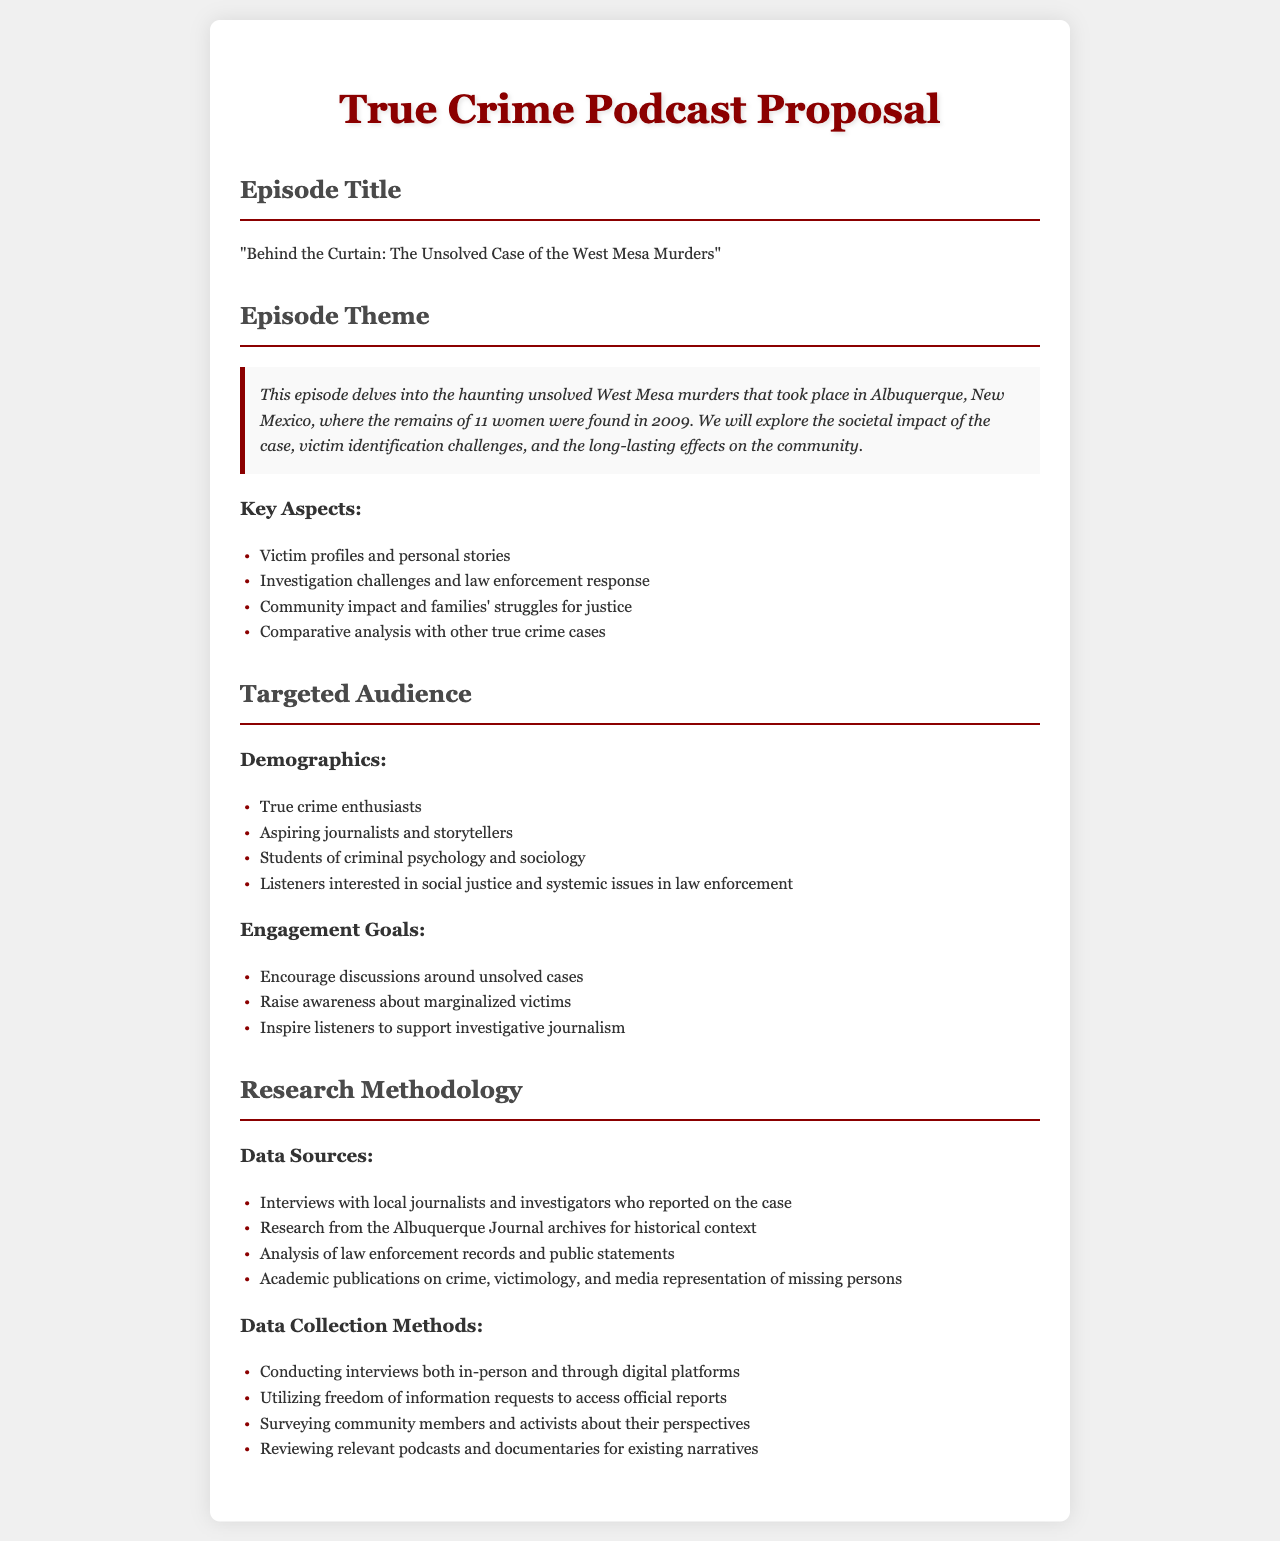What is the title of the episode? The title of the episode is stated in the document as "Behind the Curtain: The Unsolved Case of the West Mesa Murders".
Answer: "Behind the Curtain: The Unsolved Case of the West Mesa Murders" What year were the remains of 11 women found? The document specifies that the remains were found in the year 2009.
Answer: 2009 What are the key aspects of the episode theme? The document lists key aspects such as victim profiles, investigation challenges, community impact, and comparative analysis with other cases.
Answer: Victim profiles and personal stories, Investigation challenges and law enforcement response, Community impact and families' struggles for justice, Comparative analysis with other true crime cases Who is the targeted audience for the podcast episode? The document outlines demographics that include true crime enthusiasts, aspiring journalists, students, and listeners interested in social justice.
Answer: True crime enthusiasts, aspiring journalists and storytellers, students of criminal psychology and sociology, listeners interested in social justice and systemic issues in law enforcement What research method involves accessing official reports? The document mentions utilizing freedom of information requests as a method for data collection.
Answer: Freedom of information requests What community perspectives are surveyed? The document describes surveying community members and activists about their perspectives related to the case.
Answer: Community members and activists What type of media is reviewed for existing narratives? The document states that relevant podcasts and documentaries are reviewed for existing narratives related to the case.
Answer: Podcasts and documentaries 